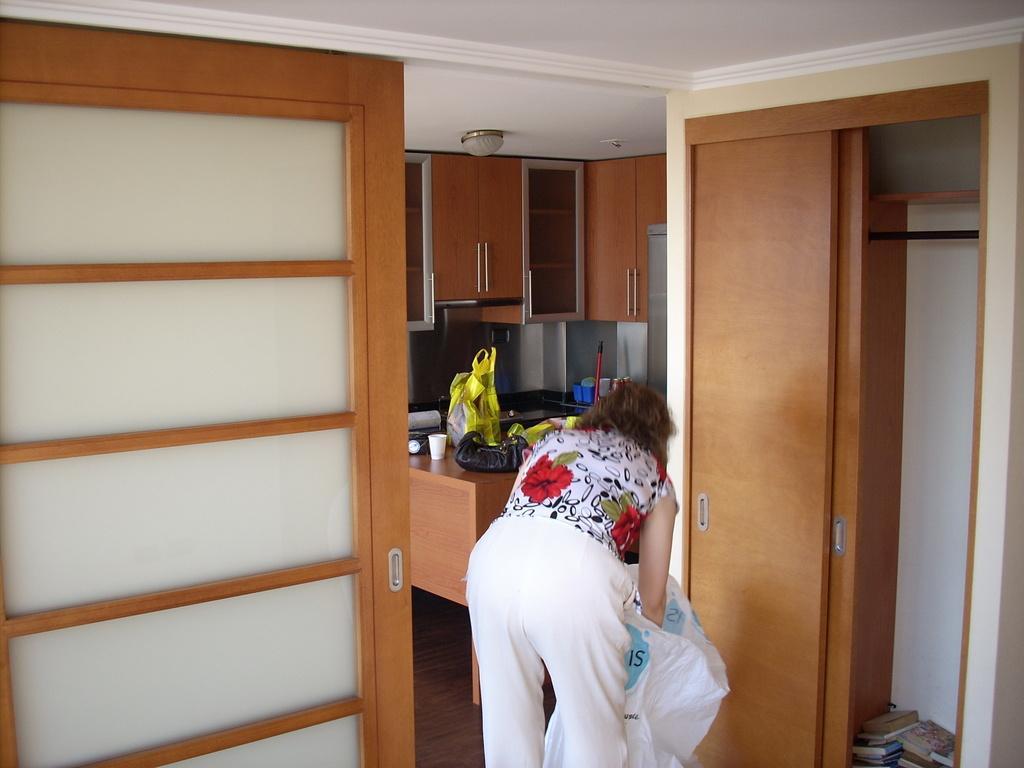Please provide a concise description of this image. In the picture i can see a woman doing some work and in the background of the picture there are some cupboards, there is a table on which there are some covers, glasses and some other things. 